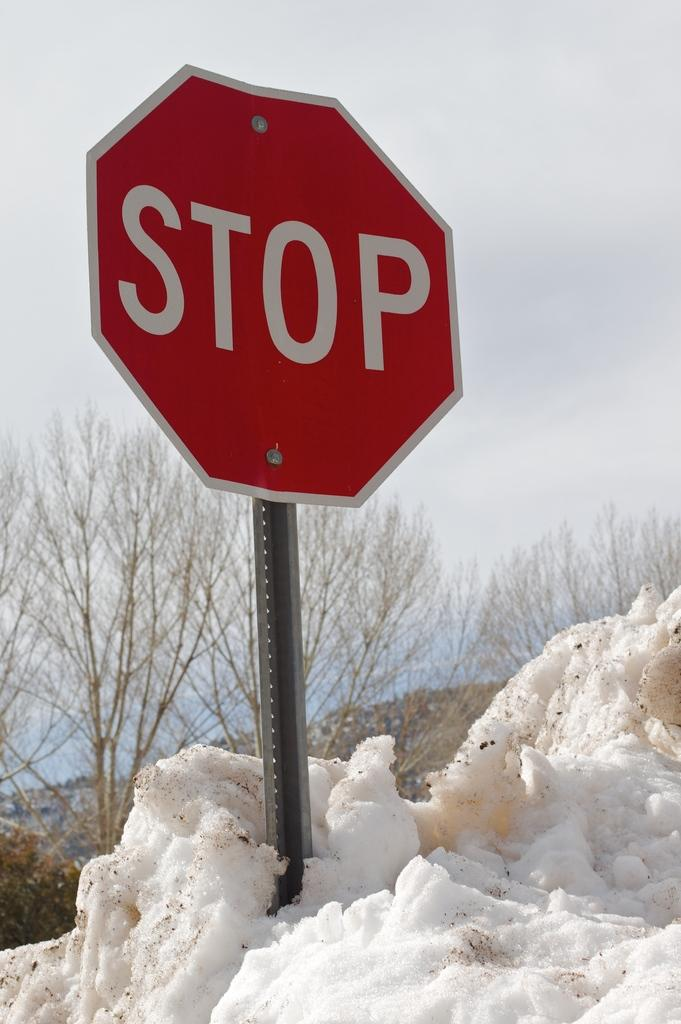<image>
Give a short and clear explanation of the subsequent image. A stop sign is poking out of a mound of snow. 